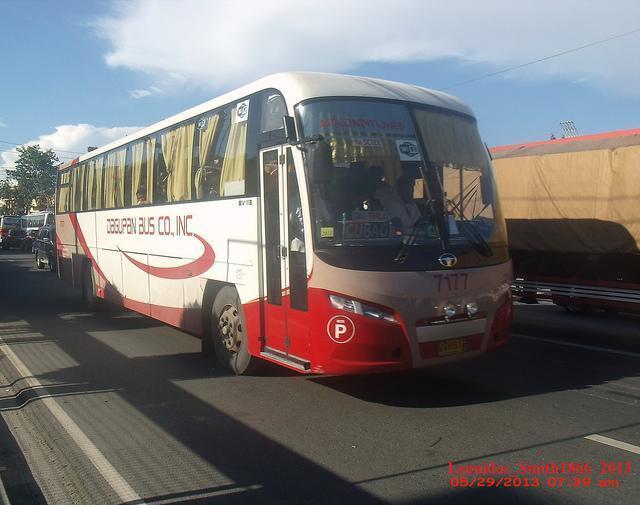How many cats are in this picture?
Give a very brief answer. 0. 